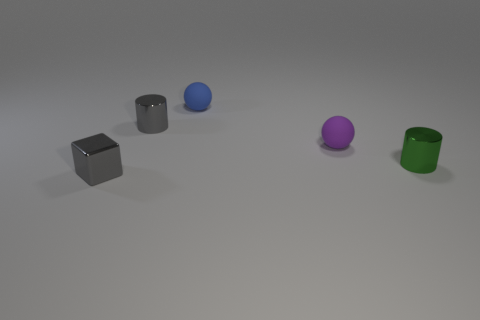What material is the tiny object that is to the left of the small green shiny object and to the right of the blue ball?
Make the answer very short. Rubber. How many other small metallic things are the same shape as the small purple thing?
Your answer should be very brief. 0. What is the cylinder behind the tiny green metal thing made of?
Provide a succinct answer. Metal. Is the number of tiny matte balls that are on the right side of the tiny blue object less than the number of shiny cylinders?
Your response must be concise. Yes. Does the tiny purple rubber object have the same shape as the small blue rubber object?
Keep it short and to the point. Yes. Are any big red cylinders visible?
Offer a very short reply. No. Is the shape of the tiny purple matte thing the same as the tiny rubber object that is to the left of the purple object?
Provide a succinct answer. Yes. There is a gray object that is in front of the tiny metallic cylinder that is on the left side of the tiny green shiny thing; what is its material?
Your answer should be compact. Metal. The small cube is what color?
Give a very brief answer. Gray. Do the object that is on the left side of the gray metal cylinder and the metallic cylinder to the left of the small blue object have the same color?
Offer a terse response. Yes. 